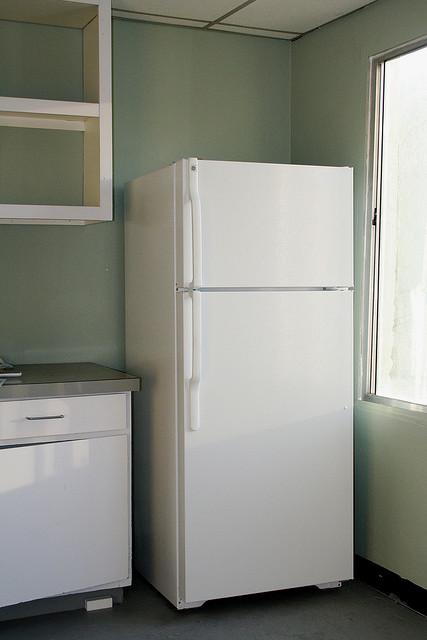Are the cabinets installed yet?
Write a very short answer. No. Does the fridge match the counters?
Write a very short answer. No. Does the fridge have a freezer?
Be succinct. Yes. 